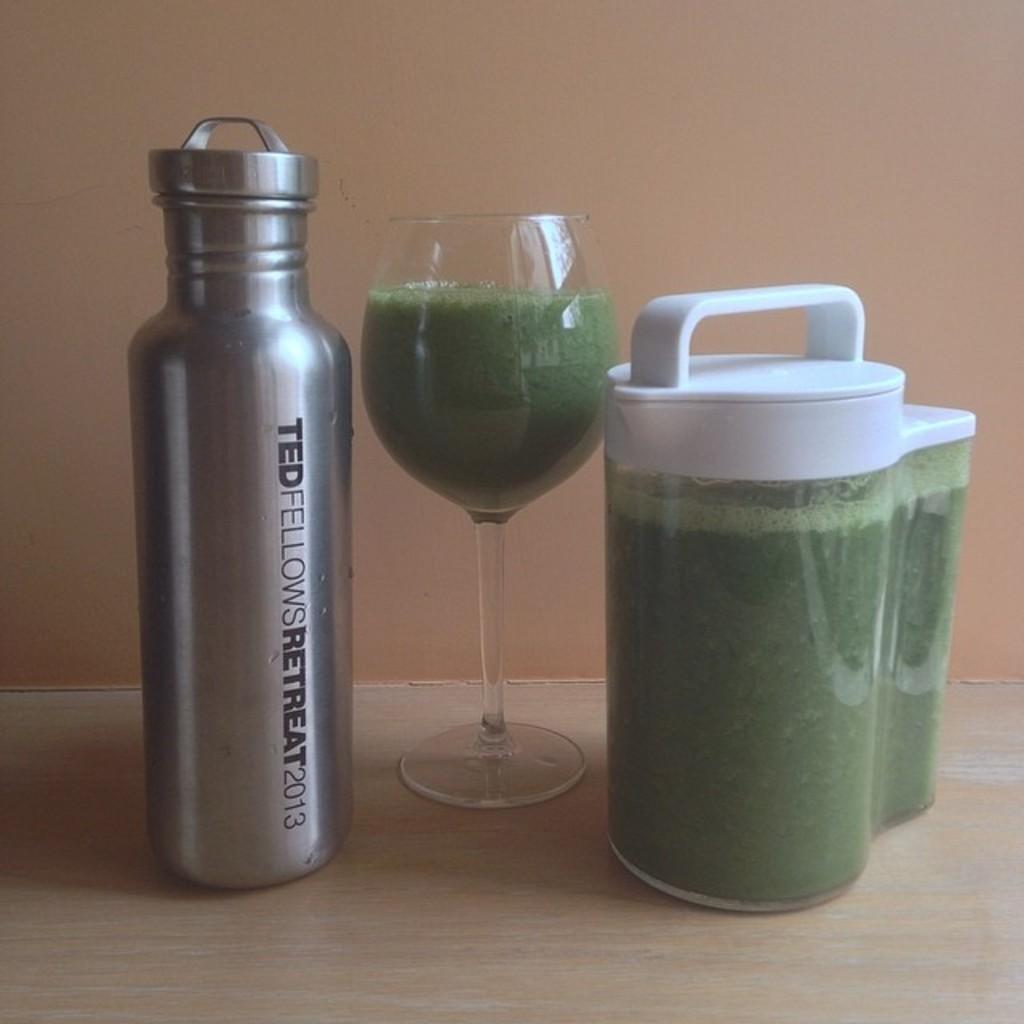What event does the bottle come from?
Your answer should be very brief. Ted fellows retreat 2013. 